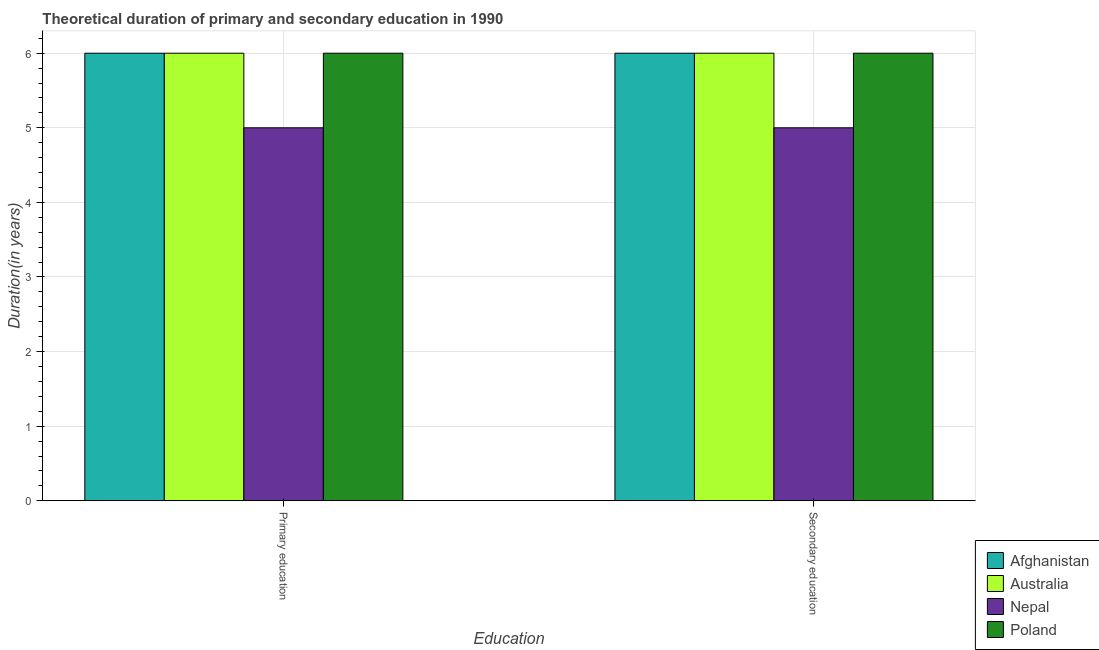How many different coloured bars are there?
Provide a short and direct response. 4. How many groups of bars are there?
Provide a succinct answer. 2. Are the number of bars on each tick of the X-axis equal?
Your response must be concise. Yes. How many bars are there on the 1st tick from the left?
Provide a succinct answer. 4. How many bars are there on the 2nd tick from the right?
Offer a very short reply. 4. What is the label of the 2nd group of bars from the left?
Offer a very short reply. Secondary education. What is the duration of secondary education in Afghanistan?
Offer a terse response. 6. Across all countries, what is the minimum duration of primary education?
Provide a succinct answer. 5. In which country was the duration of primary education maximum?
Offer a terse response. Afghanistan. In which country was the duration of primary education minimum?
Your response must be concise. Nepal. What is the total duration of primary education in the graph?
Keep it short and to the point. 23. What is the difference between the duration of secondary education in Australia and that in Poland?
Provide a short and direct response. 0. What is the difference between the duration of primary education in Poland and the duration of secondary education in Nepal?
Offer a very short reply. 1. What is the average duration of primary education per country?
Offer a very short reply. 5.75. In how many countries, is the duration of primary education greater than 1.4 years?
Make the answer very short. 4. What does the 2nd bar from the right in Primary education represents?
Provide a succinct answer. Nepal. Are all the bars in the graph horizontal?
Offer a terse response. No. How many countries are there in the graph?
Your response must be concise. 4. What is the difference between two consecutive major ticks on the Y-axis?
Offer a terse response. 1. Does the graph contain grids?
Give a very brief answer. Yes. How many legend labels are there?
Give a very brief answer. 4. What is the title of the graph?
Your response must be concise. Theoretical duration of primary and secondary education in 1990. Does "St. Kitts and Nevis" appear as one of the legend labels in the graph?
Make the answer very short. No. What is the label or title of the X-axis?
Provide a short and direct response. Education. What is the label or title of the Y-axis?
Provide a succinct answer. Duration(in years). What is the Duration(in years) in Afghanistan in Primary education?
Ensure brevity in your answer.  6. What is the Duration(in years) in Afghanistan in Secondary education?
Your answer should be very brief. 6. Across all Education, what is the maximum Duration(in years) of Nepal?
Your answer should be compact. 5. Across all Education, what is the maximum Duration(in years) of Poland?
Make the answer very short. 6. Across all Education, what is the minimum Duration(in years) of Nepal?
Offer a very short reply. 5. What is the total Duration(in years) in Australia in the graph?
Give a very brief answer. 12. What is the total Duration(in years) in Nepal in the graph?
Your answer should be very brief. 10. What is the difference between the Duration(in years) of Nepal in Primary education and that in Secondary education?
Your answer should be compact. 0. What is the difference between the Duration(in years) of Afghanistan in Primary education and the Duration(in years) of Australia in Secondary education?
Make the answer very short. 0. What is the difference between the Duration(in years) of Afghanistan in Primary education and the Duration(in years) of Nepal in Secondary education?
Provide a short and direct response. 1. What is the difference between the Duration(in years) in Australia in Primary education and the Duration(in years) in Nepal in Secondary education?
Provide a succinct answer. 1. What is the difference between the Duration(in years) of Australia in Primary education and the Duration(in years) of Poland in Secondary education?
Keep it short and to the point. 0. What is the difference between the Duration(in years) of Nepal in Primary education and the Duration(in years) of Poland in Secondary education?
Provide a short and direct response. -1. What is the average Duration(in years) of Afghanistan per Education?
Make the answer very short. 6. What is the average Duration(in years) in Australia per Education?
Provide a succinct answer. 6. What is the average Duration(in years) of Nepal per Education?
Ensure brevity in your answer.  5. What is the difference between the Duration(in years) of Afghanistan and Duration(in years) of Poland in Primary education?
Provide a short and direct response. 0. What is the difference between the Duration(in years) in Australia and Duration(in years) in Nepal in Primary education?
Your answer should be very brief. 1. What is the difference between the Duration(in years) of Australia and Duration(in years) of Poland in Primary education?
Offer a terse response. 0. What is the difference between the Duration(in years) in Nepal and Duration(in years) in Poland in Primary education?
Your response must be concise. -1. What is the difference between the Duration(in years) in Afghanistan and Duration(in years) in Nepal in Secondary education?
Give a very brief answer. 1. What is the difference between the Duration(in years) in Afghanistan and Duration(in years) in Poland in Secondary education?
Keep it short and to the point. 0. What is the difference between the Duration(in years) in Australia and Duration(in years) in Nepal in Secondary education?
Give a very brief answer. 1. What is the difference between the Duration(in years) in Australia and Duration(in years) in Poland in Secondary education?
Your answer should be very brief. 0. What is the ratio of the Duration(in years) of Nepal in Primary education to that in Secondary education?
Provide a succinct answer. 1. What is the difference between the highest and the second highest Duration(in years) in Afghanistan?
Offer a terse response. 0. What is the difference between the highest and the second highest Duration(in years) in Australia?
Keep it short and to the point. 0. What is the difference between the highest and the second highest Duration(in years) in Nepal?
Your response must be concise. 0. What is the difference between the highest and the second highest Duration(in years) of Poland?
Make the answer very short. 0. What is the difference between the highest and the lowest Duration(in years) of Afghanistan?
Keep it short and to the point. 0. What is the difference between the highest and the lowest Duration(in years) in Australia?
Your answer should be compact. 0. 